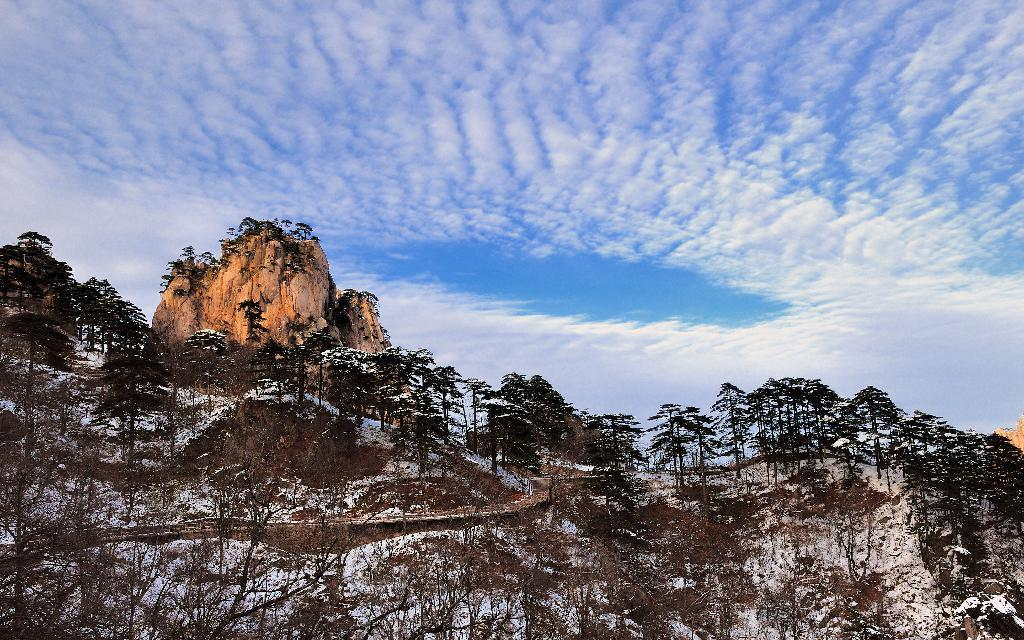What type of natural feature is present on the hill in the image? There are trees on a hill in the image. What type of man-made feature can be seen in the image? There is a road in the image. What is visible in the background of the image? The sky is visible in the background of the image. What can be observed in the sky? There are clouds in the sky. How does the ant use its nose to navigate the road in the image? There are no ants present in the image, and therefore no such activity can be observed. How does the sorting process work for the trees on the hill in the image? There is no sorting process mentioned or depicted in the image; it simply shows trees on a hill. 